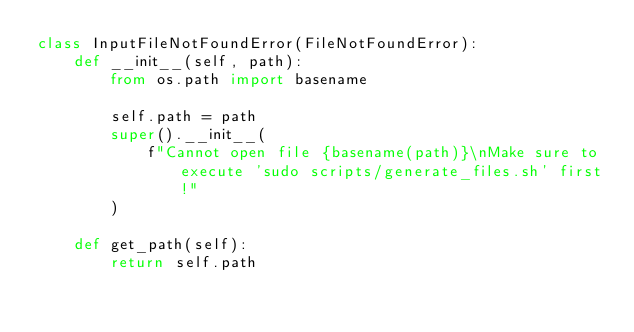Convert code to text. <code><loc_0><loc_0><loc_500><loc_500><_Python_>class InputFileNotFoundError(FileNotFoundError):
    def __init__(self, path):
        from os.path import basename

        self.path = path
        super().__init__(
            f"Cannot open file {basename(path)}\nMake sure to execute 'sudo scripts/generate_files.sh' first!"
        )

    def get_path(self):
        return self.path
</code> 